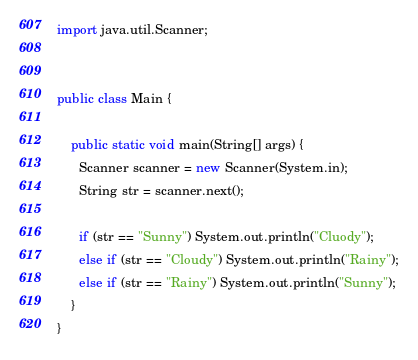<code> <loc_0><loc_0><loc_500><loc_500><_Java_>import java.util.Scanner;


public class Main {

    public static void main(String[] args) {
      Scanner scanner = new Scanner(System.in);
      String str = scanner.next();
      
      if (str == "Sunny") System.out.println("Cluody");
      else if (str == "Cloudy") System.out.println("Rainy");
      else if (str == "Rainy") System.out.println("Sunny");
    }
}</code> 